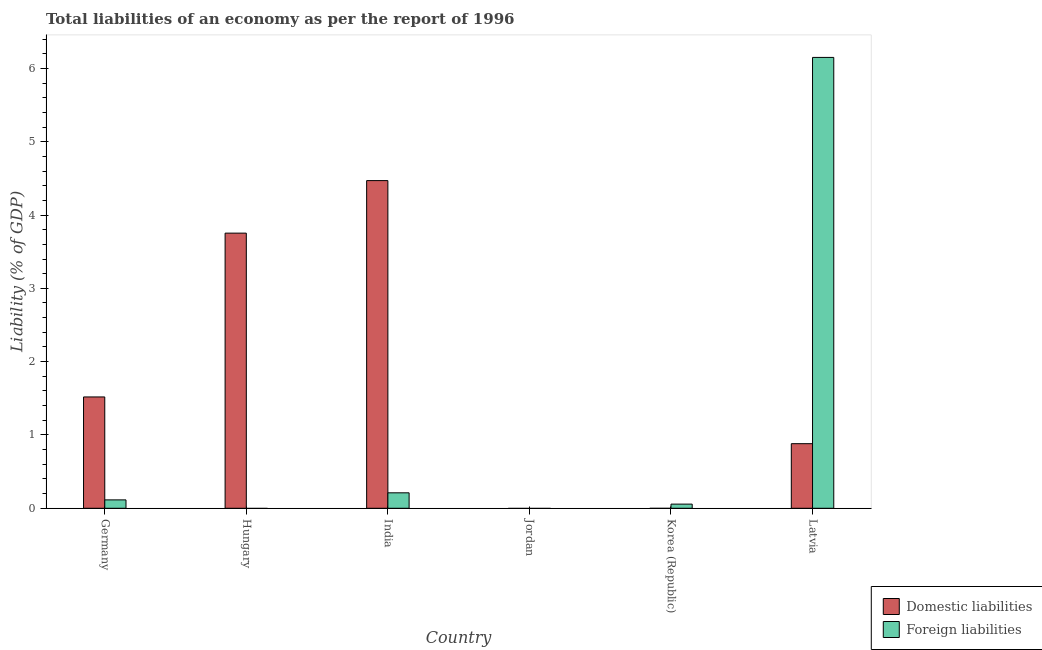Are the number of bars per tick equal to the number of legend labels?
Ensure brevity in your answer.  No. What is the label of the 3rd group of bars from the left?
Your answer should be very brief. India. Across all countries, what is the maximum incurrence of domestic liabilities?
Keep it short and to the point. 4.47. In which country was the incurrence of foreign liabilities maximum?
Offer a terse response. Latvia. What is the total incurrence of foreign liabilities in the graph?
Offer a terse response. 6.53. What is the difference between the incurrence of foreign liabilities in Korea (Republic) and that in Latvia?
Your answer should be very brief. -6.09. What is the difference between the incurrence of foreign liabilities in Hungary and the incurrence of domestic liabilities in India?
Ensure brevity in your answer.  -4.47. What is the average incurrence of foreign liabilities per country?
Offer a very short reply. 1.09. What is the difference between the incurrence of domestic liabilities and incurrence of foreign liabilities in Germany?
Your answer should be compact. 1.4. What is the ratio of the incurrence of foreign liabilities in Germany to that in Latvia?
Your answer should be very brief. 0.02. Is the difference between the incurrence of foreign liabilities in Germany and Latvia greater than the difference between the incurrence of domestic liabilities in Germany and Latvia?
Provide a short and direct response. No. What is the difference between the highest and the second highest incurrence of domestic liabilities?
Your answer should be very brief. 0.72. What is the difference between the highest and the lowest incurrence of domestic liabilities?
Give a very brief answer. 4.47. In how many countries, is the incurrence of domestic liabilities greater than the average incurrence of domestic liabilities taken over all countries?
Ensure brevity in your answer.  2. Is the sum of the incurrence of foreign liabilities in Germany and Latvia greater than the maximum incurrence of domestic liabilities across all countries?
Offer a very short reply. Yes. How many bars are there?
Provide a short and direct response. 8. Are all the bars in the graph horizontal?
Keep it short and to the point. No. How many countries are there in the graph?
Ensure brevity in your answer.  6. What is the difference between two consecutive major ticks on the Y-axis?
Offer a very short reply. 1. Are the values on the major ticks of Y-axis written in scientific E-notation?
Offer a terse response. No. Does the graph contain grids?
Your response must be concise. No. Where does the legend appear in the graph?
Give a very brief answer. Bottom right. How are the legend labels stacked?
Make the answer very short. Vertical. What is the title of the graph?
Make the answer very short. Total liabilities of an economy as per the report of 1996. What is the label or title of the X-axis?
Provide a succinct answer. Country. What is the label or title of the Y-axis?
Provide a succinct answer. Liability (% of GDP). What is the Liability (% of GDP) in Domestic liabilities in Germany?
Ensure brevity in your answer.  1.52. What is the Liability (% of GDP) of Foreign liabilities in Germany?
Ensure brevity in your answer.  0.11. What is the Liability (% of GDP) of Domestic liabilities in Hungary?
Provide a succinct answer. 3.75. What is the Liability (% of GDP) of Foreign liabilities in Hungary?
Your answer should be compact. 0. What is the Liability (% of GDP) of Domestic liabilities in India?
Ensure brevity in your answer.  4.47. What is the Liability (% of GDP) in Foreign liabilities in India?
Provide a succinct answer. 0.21. What is the Liability (% of GDP) in Domestic liabilities in Jordan?
Offer a terse response. 0. What is the Liability (% of GDP) in Foreign liabilities in Korea (Republic)?
Offer a very short reply. 0.06. What is the Liability (% of GDP) in Domestic liabilities in Latvia?
Your response must be concise. 0.88. What is the Liability (% of GDP) in Foreign liabilities in Latvia?
Keep it short and to the point. 6.15. Across all countries, what is the maximum Liability (% of GDP) of Domestic liabilities?
Offer a very short reply. 4.47. Across all countries, what is the maximum Liability (% of GDP) of Foreign liabilities?
Keep it short and to the point. 6.15. Across all countries, what is the minimum Liability (% of GDP) of Foreign liabilities?
Offer a terse response. 0. What is the total Liability (% of GDP) in Domestic liabilities in the graph?
Keep it short and to the point. 10.62. What is the total Liability (% of GDP) in Foreign liabilities in the graph?
Make the answer very short. 6.53. What is the difference between the Liability (% of GDP) of Domestic liabilities in Germany and that in Hungary?
Keep it short and to the point. -2.23. What is the difference between the Liability (% of GDP) in Domestic liabilities in Germany and that in India?
Provide a short and direct response. -2.95. What is the difference between the Liability (% of GDP) of Foreign liabilities in Germany and that in India?
Provide a short and direct response. -0.1. What is the difference between the Liability (% of GDP) of Foreign liabilities in Germany and that in Korea (Republic)?
Give a very brief answer. 0.06. What is the difference between the Liability (% of GDP) in Domestic liabilities in Germany and that in Latvia?
Your answer should be very brief. 0.64. What is the difference between the Liability (% of GDP) in Foreign liabilities in Germany and that in Latvia?
Provide a succinct answer. -6.04. What is the difference between the Liability (% of GDP) in Domestic liabilities in Hungary and that in India?
Provide a short and direct response. -0.72. What is the difference between the Liability (% of GDP) of Domestic liabilities in Hungary and that in Latvia?
Provide a succinct answer. 2.87. What is the difference between the Liability (% of GDP) in Foreign liabilities in India and that in Korea (Republic)?
Make the answer very short. 0.15. What is the difference between the Liability (% of GDP) in Domestic liabilities in India and that in Latvia?
Keep it short and to the point. 3.59. What is the difference between the Liability (% of GDP) of Foreign liabilities in India and that in Latvia?
Your response must be concise. -5.94. What is the difference between the Liability (% of GDP) of Foreign liabilities in Korea (Republic) and that in Latvia?
Offer a very short reply. -6.09. What is the difference between the Liability (% of GDP) in Domestic liabilities in Germany and the Liability (% of GDP) in Foreign liabilities in India?
Ensure brevity in your answer.  1.31. What is the difference between the Liability (% of GDP) in Domestic liabilities in Germany and the Liability (% of GDP) in Foreign liabilities in Korea (Republic)?
Provide a short and direct response. 1.46. What is the difference between the Liability (% of GDP) of Domestic liabilities in Germany and the Liability (% of GDP) of Foreign liabilities in Latvia?
Offer a terse response. -4.63. What is the difference between the Liability (% of GDP) in Domestic liabilities in Hungary and the Liability (% of GDP) in Foreign liabilities in India?
Offer a terse response. 3.54. What is the difference between the Liability (% of GDP) in Domestic liabilities in Hungary and the Liability (% of GDP) in Foreign liabilities in Korea (Republic)?
Provide a succinct answer. 3.7. What is the difference between the Liability (% of GDP) of Domestic liabilities in Hungary and the Liability (% of GDP) of Foreign liabilities in Latvia?
Your answer should be very brief. -2.4. What is the difference between the Liability (% of GDP) in Domestic liabilities in India and the Liability (% of GDP) in Foreign liabilities in Korea (Republic)?
Provide a succinct answer. 4.41. What is the difference between the Liability (% of GDP) of Domestic liabilities in India and the Liability (% of GDP) of Foreign liabilities in Latvia?
Ensure brevity in your answer.  -1.68. What is the average Liability (% of GDP) in Domestic liabilities per country?
Make the answer very short. 1.77. What is the average Liability (% of GDP) of Foreign liabilities per country?
Keep it short and to the point. 1.09. What is the difference between the Liability (% of GDP) in Domestic liabilities and Liability (% of GDP) in Foreign liabilities in Germany?
Give a very brief answer. 1.4. What is the difference between the Liability (% of GDP) in Domestic liabilities and Liability (% of GDP) in Foreign liabilities in India?
Make the answer very short. 4.26. What is the difference between the Liability (% of GDP) of Domestic liabilities and Liability (% of GDP) of Foreign liabilities in Latvia?
Offer a very short reply. -5.27. What is the ratio of the Liability (% of GDP) in Domestic liabilities in Germany to that in Hungary?
Provide a short and direct response. 0.4. What is the ratio of the Liability (% of GDP) in Domestic liabilities in Germany to that in India?
Your answer should be compact. 0.34. What is the ratio of the Liability (% of GDP) of Foreign liabilities in Germany to that in India?
Provide a short and direct response. 0.54. What is the ratio of the Liability (% of GDP) in Foreign liabilities in Germany to that in Korea (Republic)?
Make the answer very short. 2.02. What is the ratio of the Liability (% of GDP) in Domestic liabilities in Germany to that in Latvia?
Your answer should be compact. 1.72. What is the ratio of the Liability (% of GDP) of Foreign liabilities in Germany to that in Latvia?
Your response must be concise. 0.02. What is the ratio of the Liability (% of GDP) in Domestic liabilities in Hungary to that in India?
Offer a terse response. 0.84. What is the ratio of the Liability (% of GDP) of Domestic liabilities in Hungary to that in Latvia?
Ensure brevity in your answer.  4.26. What is the ratio of the Liability (% of GDP) in Foreign liabilities in India to that in Korea (Republic)?
Offer a terse response. 3.72. What is the ratio of the Liability (% of GDP) of Domestic liabilities in India to that in Latvia?
Provide a short and direct response. 5.07. What is the ratio of the Liability (% of GDP) in Foreign liabilities in India to that in Latvia?
Keep it short and to the point. 0.03. What is the ratio of the Liability (% of GDP) in Foreign liabilities in Korea (Republic) to that in Latvia?
Give a very brief answer. 0.01. What is the difference between the highest and the second highest Liability (% of GDP) in Domestic liabilities?
Offer a very short reply. 0.72. What is the difference between the highest and the second highest Liability (% of GDP) in Foreign liabilities?
Make the answer very short. 5.94. What is the difference between the highest and the lowest Liability (% of GDP) of Domestic liabilities?
Provide a short and direct response. 4.47. What is the difference between the highest and the lowest Liability (% of GDP) of Foreign liabilities?
Offer a terse response. 6.15. 